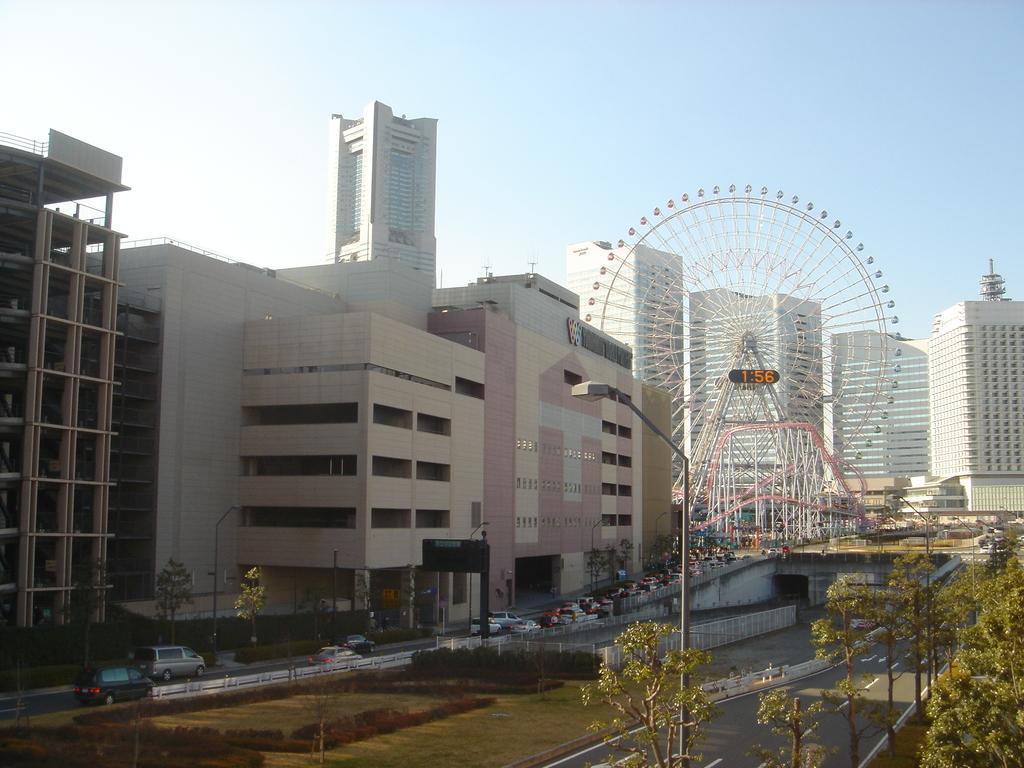Could you give a brief overview of what you see in this image? In the image we can see there are lot of trees and there are ground is covered with grass. There are plants, trees and bushes on the ground. There are buildings and there is a huge giant wheel kept on the road. There is clear sky on the top. 